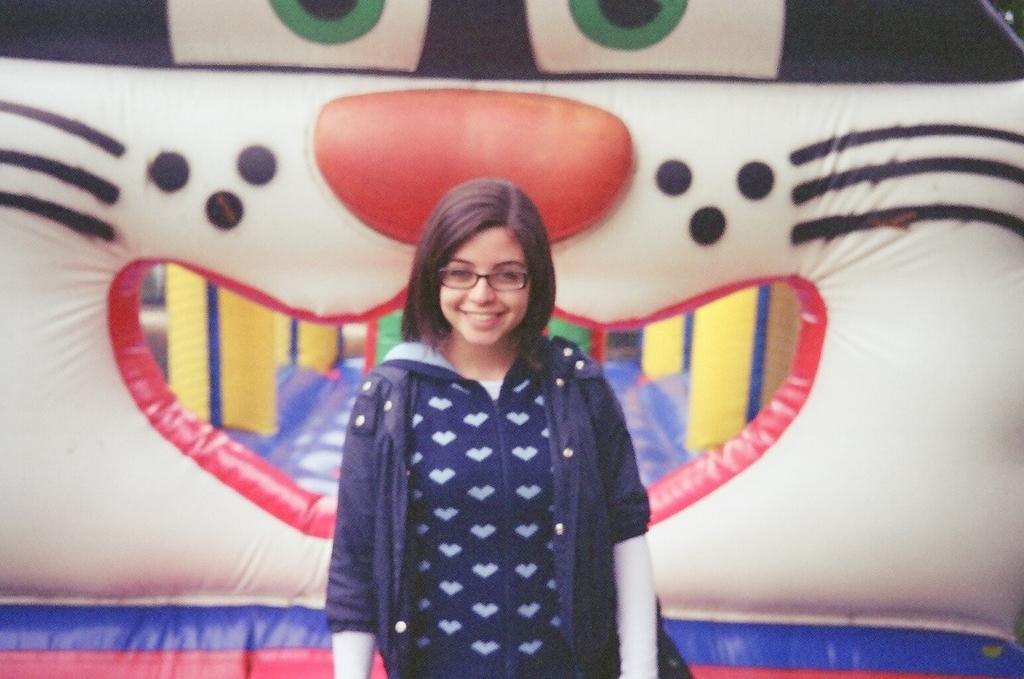What is the main subject of the image? The main subject of the image is a woman standing. Can you describe the woman's attire? The woman is wearing clothes. What accessory is the woman wearing on her face? The woman is wearing spectacles. What can be seen behind the woman in the image? There is an inflatable teddy behind the woman. What type of branch can be seen growing from the woman's head in the image? There is no branch growing from the woman's head in the image. 